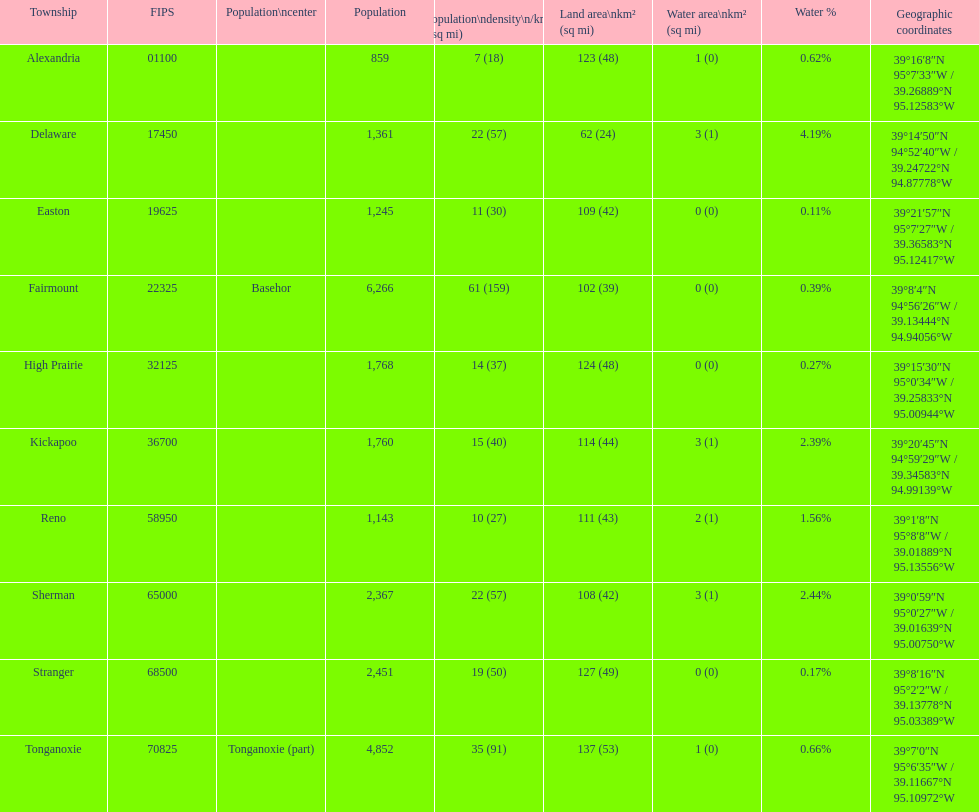How many townships have populations over 2,000? 4. 